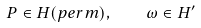<formula> <loc_0><loc_0><loc_500><loc_500>P \in H ( p e r m ) , \quad \omega \in H ^ { \prime }</formula> 